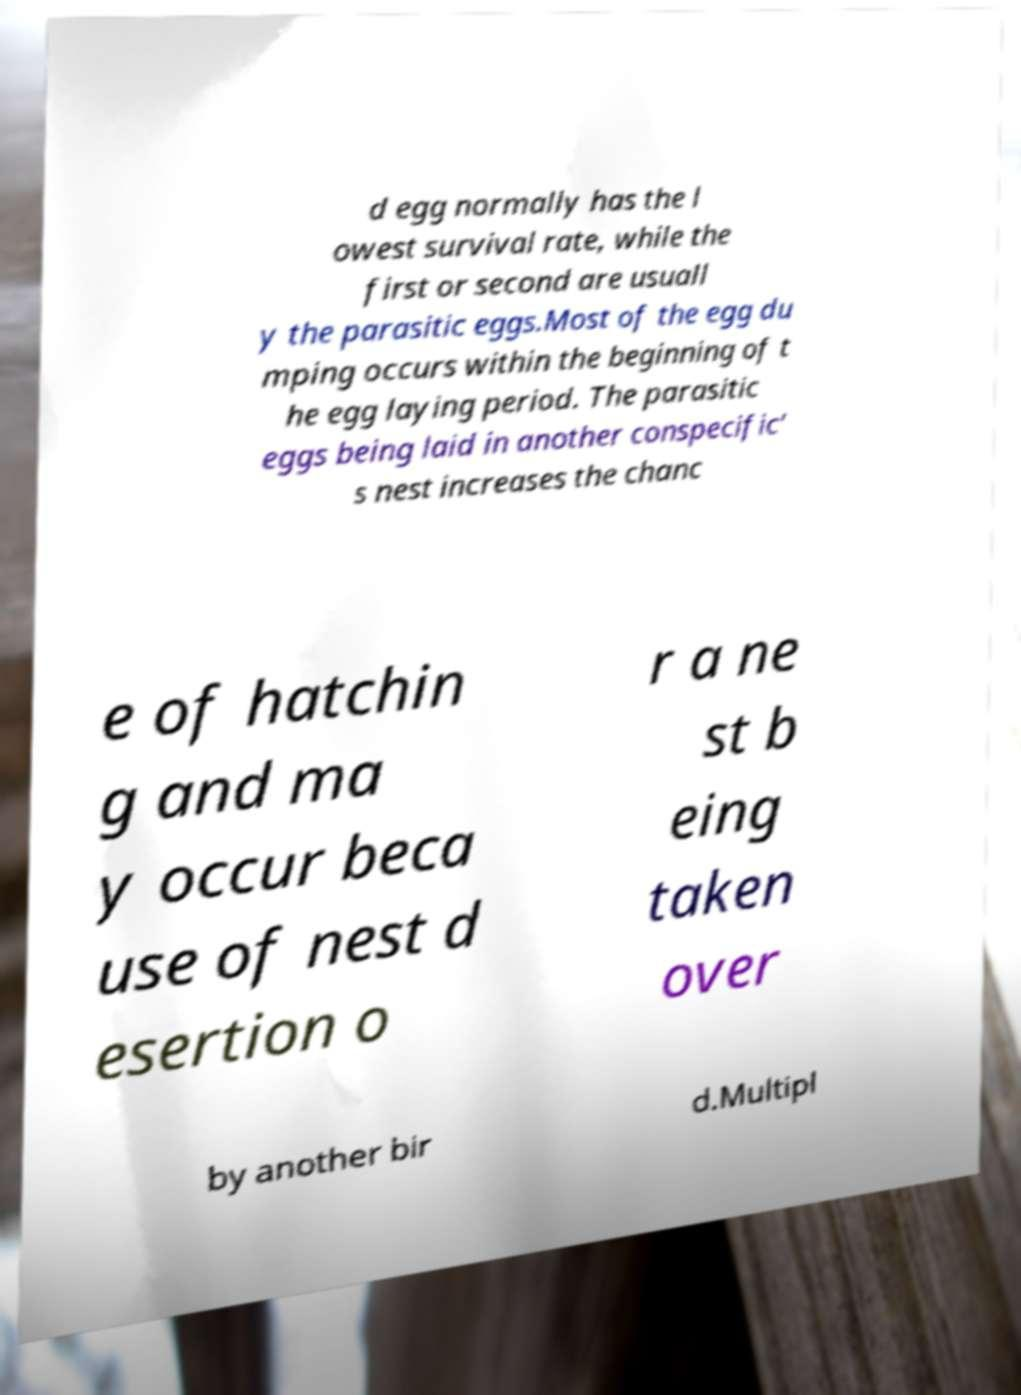There's text embedded in this image that I need extracted. Can you transcribe it verbatim? d egg normally has the l owest survival rate, while the first or second are usuall y the parasitic eggs.Most of the egg du mping occurs within the beginning of t he egg laying period. The parasitic eggs being laid in another conspecific’ s nest increases the chanc e of hatchin g and ma y occur beca use of nest d esertion o r a ne st b eing taken over by another bir d.Multipl 